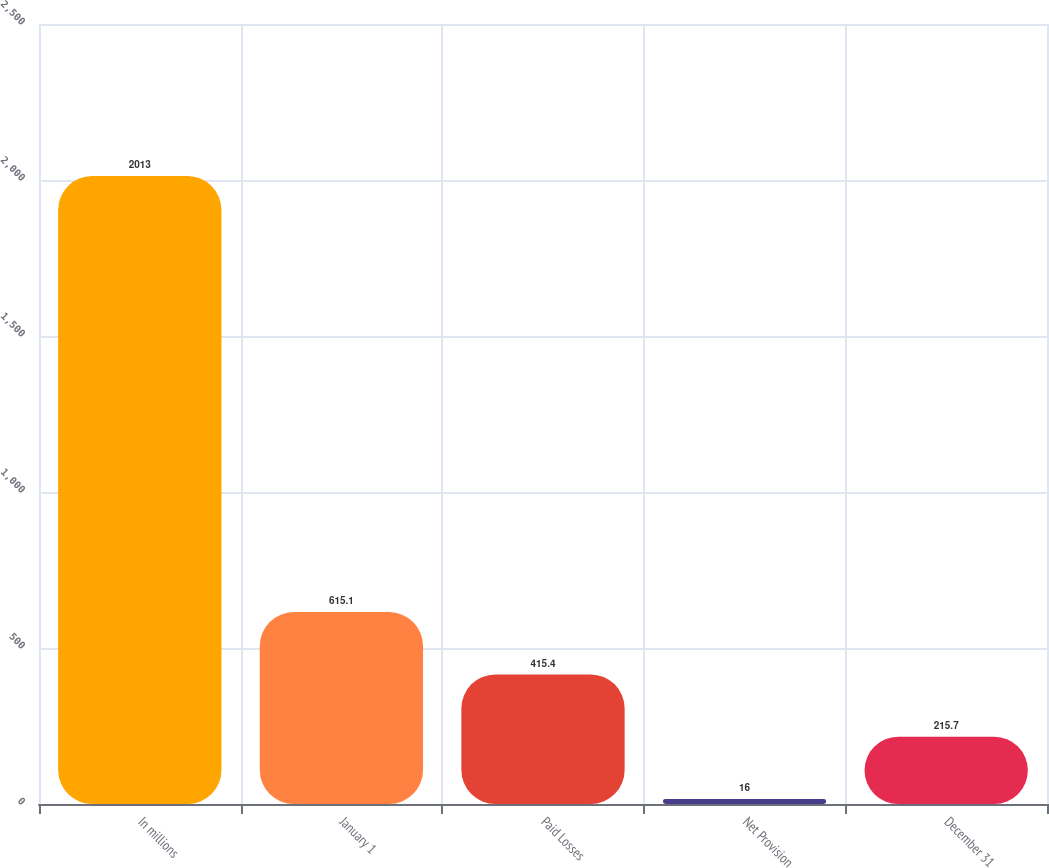Convert chart. <chart><loc_0><loc_0><loc_500><loc_500><bar_chart><fcel>In millions<fcel>January 1<fcel>Paid Losses<fcel>Net Provision<fcel>December 31<nl><fcel>2013<fcel>615.1<fcel>415.4<fcel>16<fcel>215.7<nl></chart> 